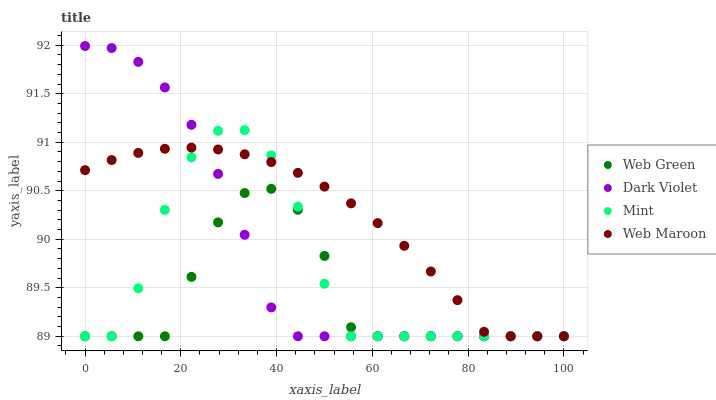Does Web Green have the minimum area under the curve?
Answer yes or no. Yes. Does Web Maroon have the maximum area under the curve?
Answer yes or no. Yes. Does Mint have the minimum area under the curve?
Answer yes or no. No. Does Mint have the maximum area under the curve?
Answer yes or no. No. Is Web Maroon the smoothest?
Answer yes or no. Yes. Is Mint the roughest?
Answer yes or no. Yes. Is Dark Violet the smoothest?
Answer yes or no. No. Is Dark Violet the roughest?
Answer yes or no. No. Does Web Maroon have the lowest value?
Answer yes or no. Yes. Does Dark Violet have the highest value?
Answer yes or no. Yes. Does Mint have the highest value?
Answer yes or no. No. Does Dark Violet intersect Web Maroon?
Answer yes or no. Yes. Is Dark Violet less than Web Maroon?
Answer yes or no. No. Is Dark Violet greater than Web Maroon?
Answer yes or no. No. 